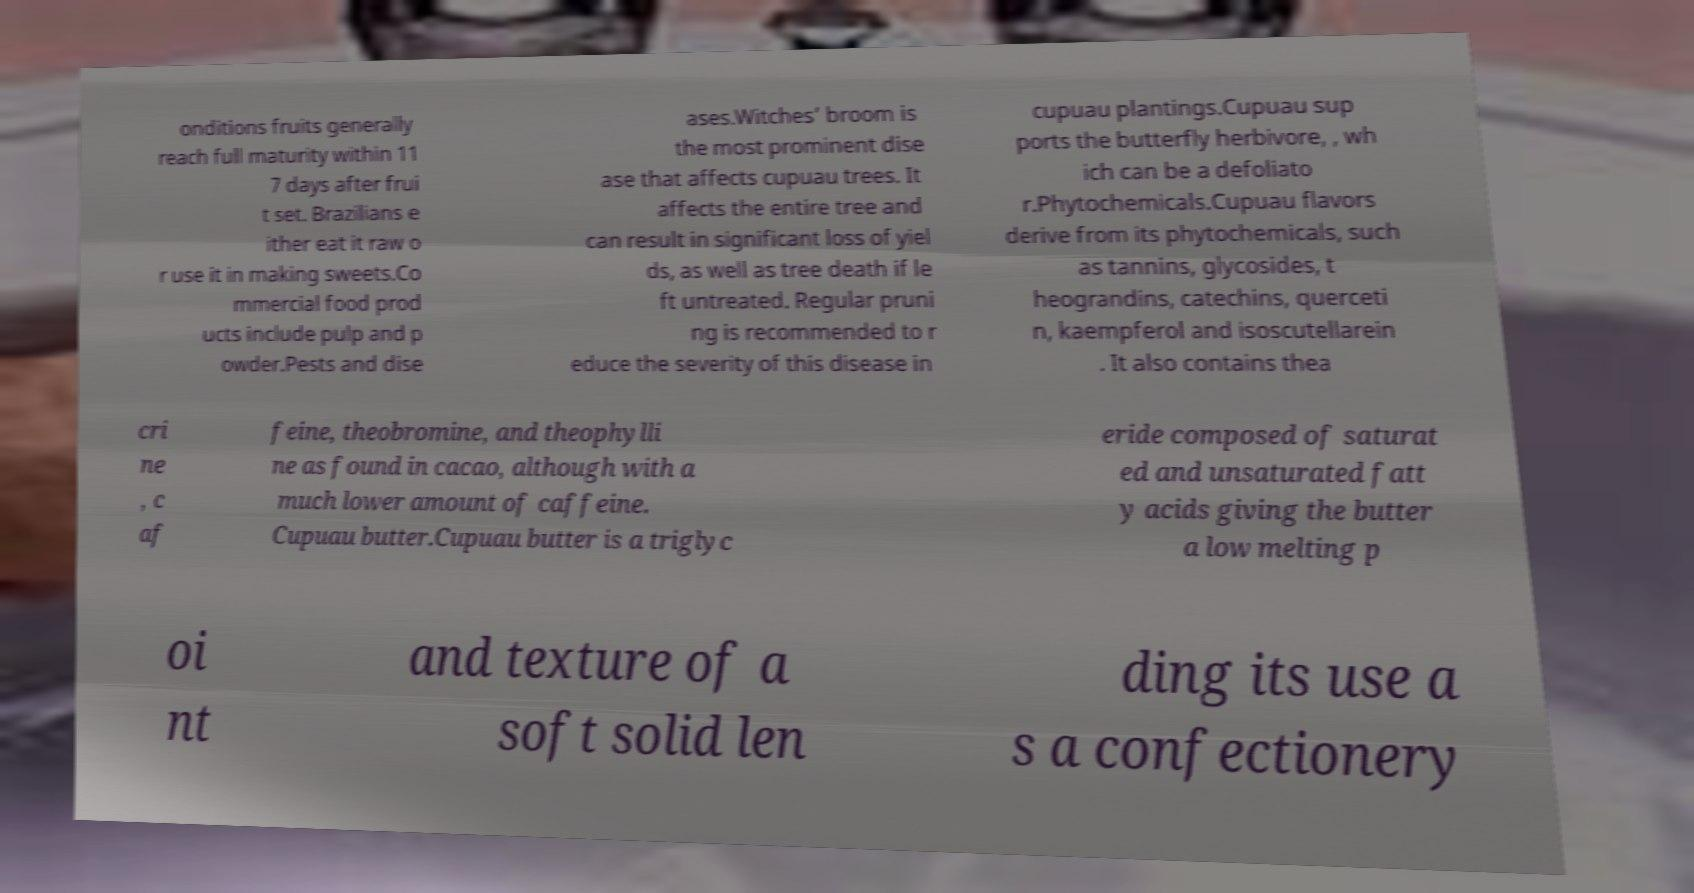Please read and relay the text visible in this image. What does it say? onditions fruits generally reach full maturity within 11 7 days after frui t set. Brazilians e ither eat it raw o r use it in making sweets.Co mmercial food prod ucts include pulp and p owder.Pests and dise ases.Witches’ broom is the most prominent dise ase that affects cupuau trees. It affects the entire tree and can result in significant loss of yiel ds, as well as tree death if le ft untreated. Regular pruni ng is recommended to r educe the severity of this disease in cupuau plantings.Cupuau sup ports the butterfly herbivore, , wh ich can be a defoliato r.Phytochemicals.Cupuau flavors derive from its phytochemicals, such as tannins, glycosides, t heograndins, catechins, querceti n, kaempferol and isoscutellarein . It also contains thea cri ne , c af feine, theobromine, and theophylli ne as found in cacao, although with a much lower amount of caffeine. Cupuau butter.Cupuau butter is a triglyc eride composed of saturat ed and unsaturated fatt y acids giving the butter a low melting p oi nt and texture of a soft solid len ding its use a s a confectionery 